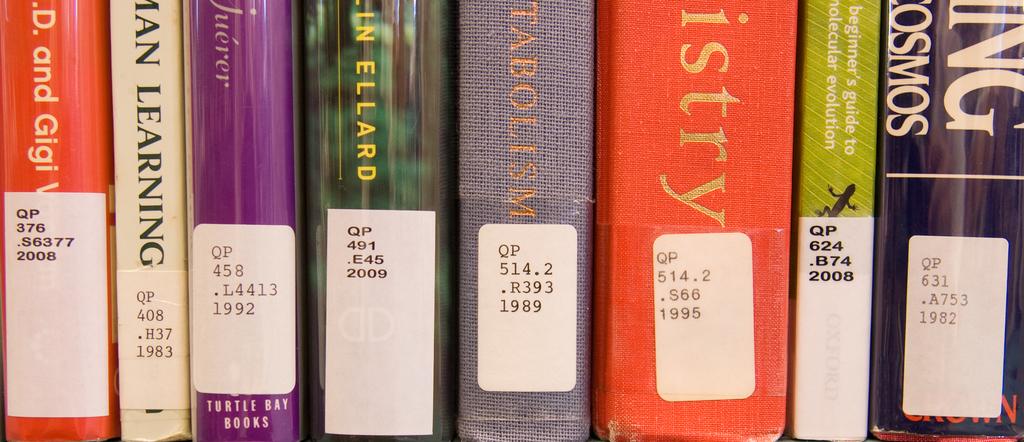What is the first two letters on each sticker?
Keep it short and to the point. Qp. 